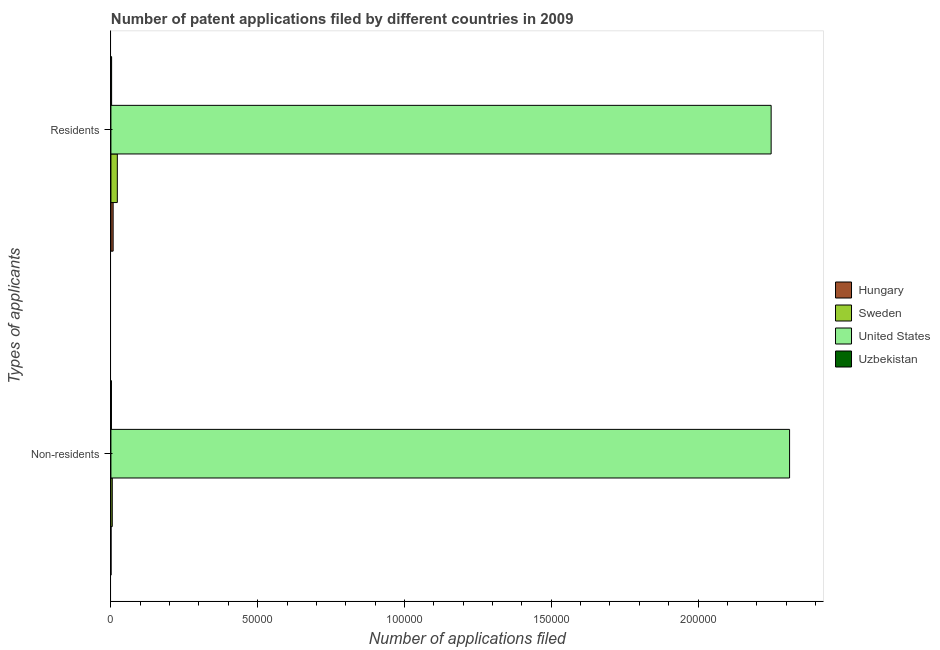How many different coloured bars are there?
Provide a short and direct response. 4. Are the number of bars per tick equal to the number of legend labels?
Your response must be concise. Yes. What is the label of the 2nd group of bars from the top?
Make the answer very short. Non-residents. What is the number of patent applications by residents in Sweden?
Provide a short and direct response. 2186. Across all countries, what is the maximum number of patent applications by residents?
Provide a short and direct response. 2.25e+05. Across all countries, what is the minimum number of patent applications by non residents?
Make the answer very short. 30. In which country was the number of patent applications by residents minimum?
Keep it short and to the point. Uzbekistan. What is the total number of patent applications by residents in the graph?
Give a very brief answer. 2.28e+05. What is the difference between the number of patent applications by non residents in United States and that in Uzbekistan?
Your answer should be very brief. 2.31e+05. What is the difference between the number of patent applications by non residents in United States and the number of patent applications by residents in Sweden?
Your answer should be very brief. 2.29e+05. What is the average number of patent applications by residents per country?
Your response must be concise. 5.70e+04. What is the difference between the number of patent applications by residents and number of patent applications by non residents in Uzbekistan?
Ensure brevity in your answer.  64. In how many countries, is the number of patent applications by residents greater than 210000 ?
Provide a succinct answer. 1. What is the ratio of the number of patent applications by residents in Hungary to that in Uzbekistan?
Your response must be concise. 3.18. Is the number of patent applications by residents in Uzbekistan less than that in Sweden?
Offer a very short reply. Yes. What does the 3rd bar from the top in Non-residents represents?
Your answer should be compact. Sweden. What does the 1st bar from the bottom in Residents represents?
Give a very brief answer. Hungary. How many bars are there?
Your response must be concise. 8. What is the difference between two consecutive major ticks on the X-axis?
Your answer should be compact. 5.00e+04. How are the legend labels stacked?
Keep it short and to the point. Vertical. What is the title of the graph?
Offer a terse response. Number of patent applications filed by different countries in 2009. What is the label or title of the X-axis?
Offer a terse response. Number of applications filed. What is the label or title of the Y-axis?
Your answer should be very brief. Types of applicants. What is the Number of applications filed in Sweden in Non-residents?
Keep it short and to the point. 463. What is the Number of applications filed in United States in Non-residents?
Provide a short and direct response. 2.31e+05. What is the Number of applications filed of Uzbekistan in Non-residents?
Offer a very short reply. 174. What is the Number of applications filed of Hungary in Residents?
Your answer should be very brief. 757. What is the Number of applications filed of Sweden in Residents?
Provide a short and direct response. 2186. What is the Number of applications filed of United States in Residents?
Your answer should be very brief. 2.25e+05. What is the Number of applications filed in Uzbekistan in Residents?
Your answer should be very brief. 238. Across all Types of applicants, what is the maximum Number of applications filed of Hungary?
Ensure brevity in your answer.  757. Across all Types of applicants, what is the maximum Number of applications filed of Sweden?
Offer a very short reply. 2186. Across all Types of applicants, what is the maximum Number of applications filed in United States?
Keep it short and to the point. 2.31e+05. Across all Types of applicants, what is the maximum Number of applications filed of Uzbekistan?
Your response must be concise. 238. Across all Types of applicants, what is the minimum Number of applications filed in Hungary?
Offer a terse response. 30. Across all Types of applicants, what is the minimum Number of applications filed in Sweden?
Ensure brevity in your answer.  463. Across all Types of applicants, what is the minimum Number of applications filed in United States?
Ensure brevity in your answer.  2.25e+05. Across all Types of applicants, what is the minimum Number of applications filed in Uzbekistan?
Your answer should be very brief. 174. What is the total Number of applications filed in Hungary in the graph?
Offer a terse response. 787. What is the total Number of applications filed in Sweden in the graph?
Provide a short and direct response. 2649. What is the total Number of applications filed of United States in the graph?
Ensure brevity in your answer.  4.56e+05. What is the total Number of applications filed in Uzbekistan in the graph?
Ensure brevity in your answer.  412. What is the difference between the Number of applications filed of Hungary in Non-residents and that in Residents?
Give a very brief answer. -727. What is the difference between the Number of applications filed of Sweden in Non-residents and that in Residents?
Offer a very short reply. -1723. What is the difference between the Number of applications filed of United States in Non-residents and that in Residents?
Provide a short and direct response. 6282. What is the difference between the Number of applications filed of Uzbekistan in Non-residents and that in Residents?
Provide a short and direct response. -64. What is the difference between the Number of applications filed in Hungary in Non-residents and the Number of applications filed in Sweden in Residents?
Provide a succinct answer. -2156. What is the difference between the Number of applications filed of Hungary in Non-residents and the Number of applications filed of United States in Residents?
Ensure brevity in your answer.  -2.25e+05. What is the difference between the Number of applications filed of Hungary in Non-residents and the Number of applications filed of Uzbekistan in Residents?
Offer a terse response. -208. What is the difference between the Number of applications filed in Sweden in Non-residents and the Number of applications filed in United States in Residents?
Provide a short and direct response. -2.24e+05. What is the difference between the Number of applications filed of Sweden in Non-residents and the Number of applications filed of Uzbekistan in Residents?
Your answer should be very brief. 225. What is the difference between the Number of applications filed of United States in Non-residents and the Number of applications filed of Uzbekistan in Residents?
Keep it short and to the point. 2.31e+05. What is the average Number of applications filed of Hungary per Types of applicants?
Your answer should be very brief. 393.5. What is the average Number of applications filed in Sweden per Types of applicants?
Your response must be concise. 1324.5. What is the average Number of applications filed of United States per Types of applicants?
Give a very brief answer. 2.28e+05. What is the average Number of applications filed in Uzbekistan per Types of applicants?
Ensure brevity in your answer.  206. What is the difference between the Number of applications filed in Hungary and Number of applications filed in Sweden in Non-residents?
Provide a succinct answer. -433. What is the difference between the Number of applications filed in Hungary and Number of applications filed in United States in Non-residents?
Your response must be concise. -2.31e+05. What is the difference between the Number of applications filed of Hungary and Number of applications filed of Uzbekistan in Non-residents?
Your answer should be very brief. -144. What is the difference between the Number of applications filed of Sweden and Number of applications filed of United States in Non-residents?
Offer a terse response. -2.31e+05. What is the difference between the Number of applications filed in Sweden and Number of applications filed in Uzbekistan in Non-residents?
Your response must be concise. 289. What is the difference between the Number of applications filed in United States and Number of applications filed in Uzbekistan in Non-residents?
Provide a succinct answer. 2.31e+05. What is the difference between the Number of applications filed in Hungary and Number of applications filed in Sweden in Residents?
Provide a short and direct response. -1429. What is the difference between the Number of applications filed in Hungary and Number of applications filed in United States in Residents?
Provide a succinct answer. -2.24e+05. What is the difference between the Number of applications filed in Hungary and Number of applications filed in Uzbekistan in Residents?
Your response must be concise. 519. What is the difference between the Number of applications filed of Sweden and Number of applications filed of United States in Residents?
Ensure brevity in your answer.  -2.23e+05. What is the difference between the Number of applications filed in Sweden and Number of applications filed in Uzbekistan in Residents?
Offer a terse response. 1948. What is the difference between the Number of applications filed in United States and Number of applications filed in Uzbekistan in Residents?
Your response must be concise. 2.25e+05. What is the ratio of the Number of applications filed of Hungary in Non-residents to that in Residents?
Offer a terse response. 0.04. What is the ratio of the Number of applications filed in Sweden in Non-residents to that in Residents?
Your answer should be compact. 0.21. What is the ratio of the Number of applications filed in United States in Non-residents to that in Residents?
Give a very brief answer. 1.03. What is the ratio of the Number of applications filed in Uzbekistan in Non-residents to that in Residents?
Give a very brief answer. 0.73. What is the difference between the highest and the second highest Number of applications filed of Hungary?
Provide a short and direct response. 727. What is the difference between the highest and the second highest Number of applications filed of Sweden?
Offer a very short reply. 1723. What is the difference between the highest and the second highest Number of applications filed of United States?
Offer a terse response. 6282. What is the difference between the highest and the lowest Number of applications filed of Hungary?
Your answer should be very brief. 727. What is the difference between the highest and the lowest Number of applications filed in Sweden?
Keep it short and to the point. 1723. What is the difference between the highest and the lowest Number of applications filed of United States?
Offer a very short reply. 6282. 